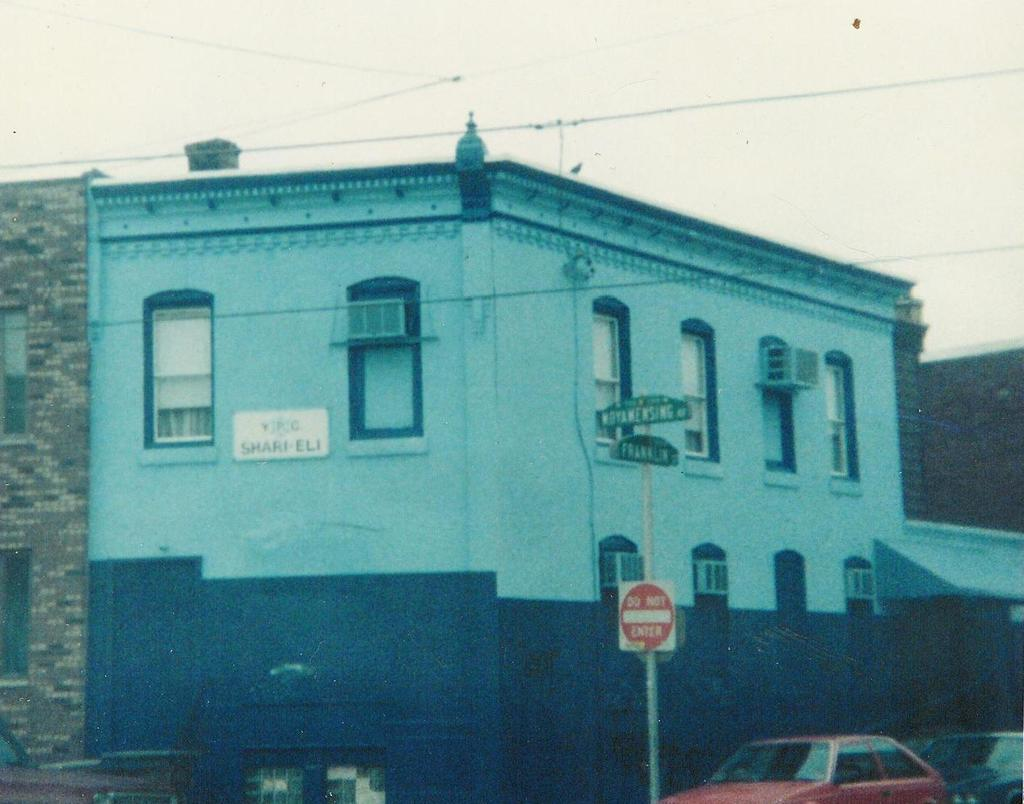Provide a one-sentence caption for the provided image. A do not enter sign on a road near a building. 